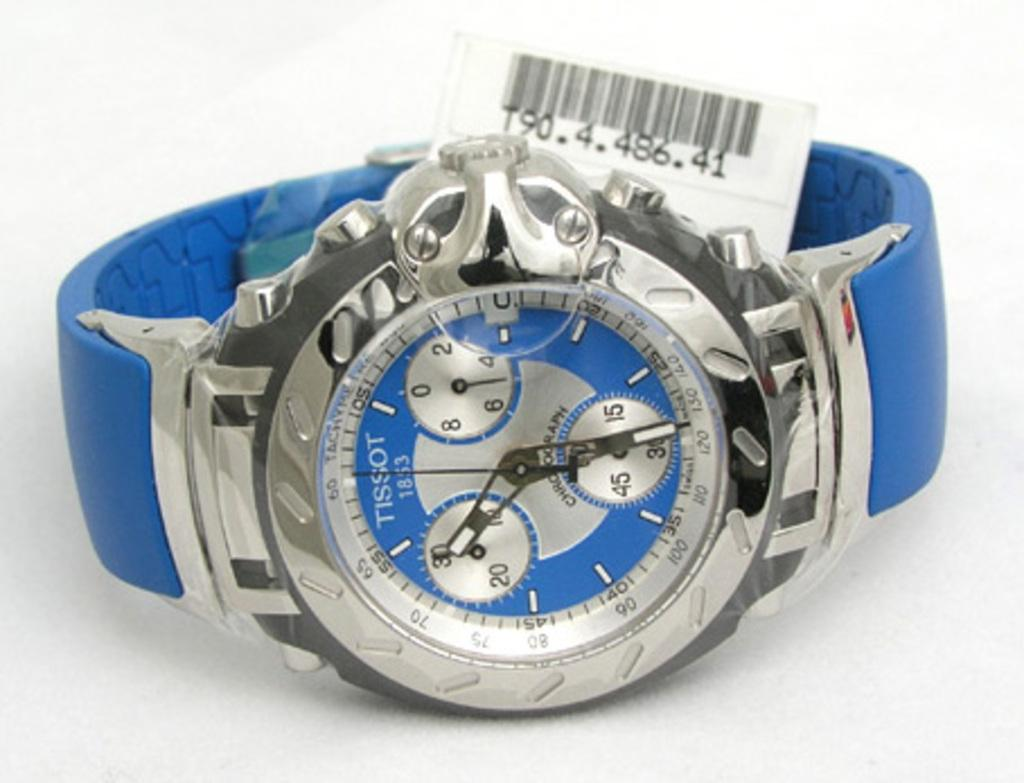Provide a one-sentence caption for the provided image. Blue and silver stopwatch with a tag on it made by Tissot. 